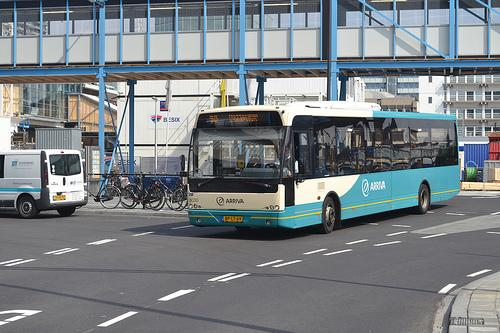Describe the state of the painted lines on the street. The painted lines on the street are white and appear to be broken. Describe the type of windows present on the bus. The windows on the bus are tinted. Provide a brief description of the central object in the image. A large blue and white passenger bus is parked on a street with various features like a tire, windshield, and license plate visible. Talk about the items parked next to the bus in the image. There are bicycles parked next to the bus, standing at a rack on the roadside. Talk about the type of wheels the bus has. The bus has round, inflated, and black tires. Describe the location of the bus in the image. The bus is located on the road with other vehicles, a yellow pole in the background, and blue poles above it. Mention the central object and its color in the image. The central object is a bus, which is blue and white in color. Mention the license plate and its color in the image. The bus has a yellow license plate. Mention any text visible on the bus. There is white writing, which includes a name and logo, on the side of the bus. Mention any large objects present in the image's background. There is large yellow construction equipment and a window on the building in the background. 